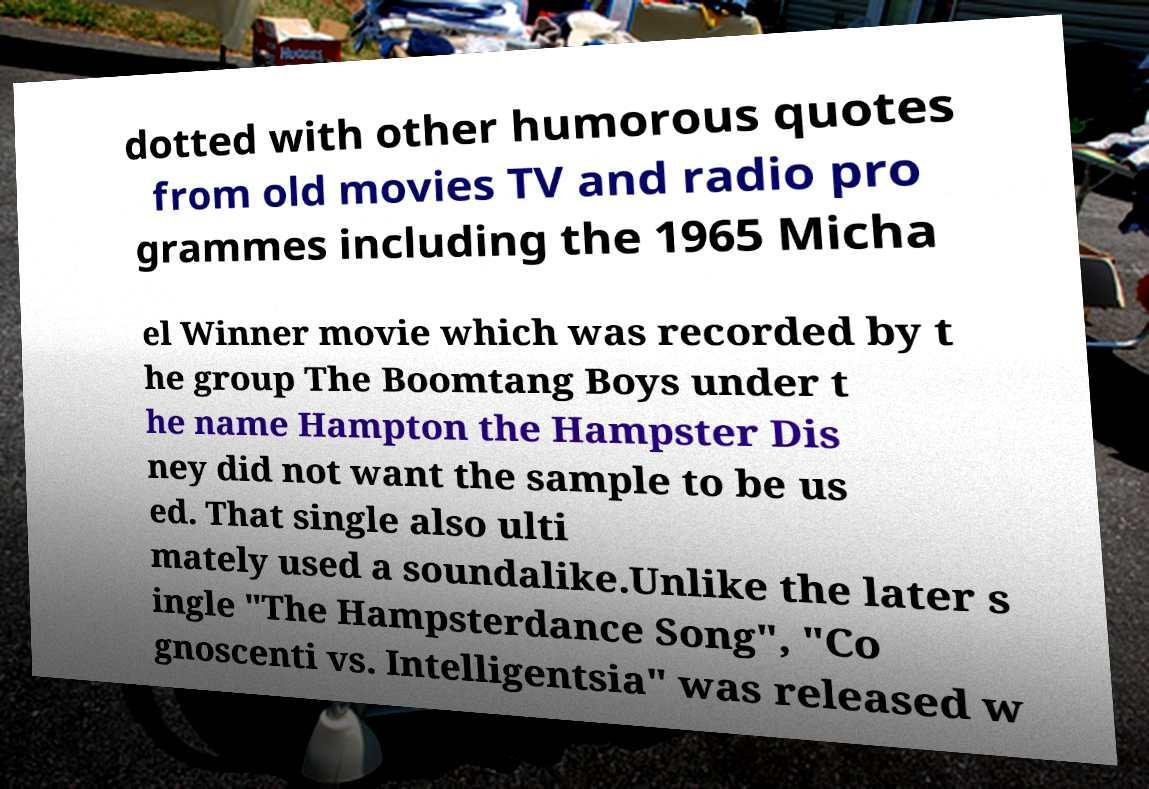Can you read and provide the text displayed in the image?This photo seems to have some interesting text. Can you extract and type it out for me? dotted with other humorous quotes from old movies TV and radio pro grammes including the 1965 Micha el Winner movie which was recorded by t he group The Boomtang Boys under t he name Hampton the Hampster Dis ney did not want the sample to be us ed. That single also ulti mately used a soundalike.Unlike the later s ingle "The Hampsterdance Song", "Co gnoscenti vs. Intelligentsia" was released w 